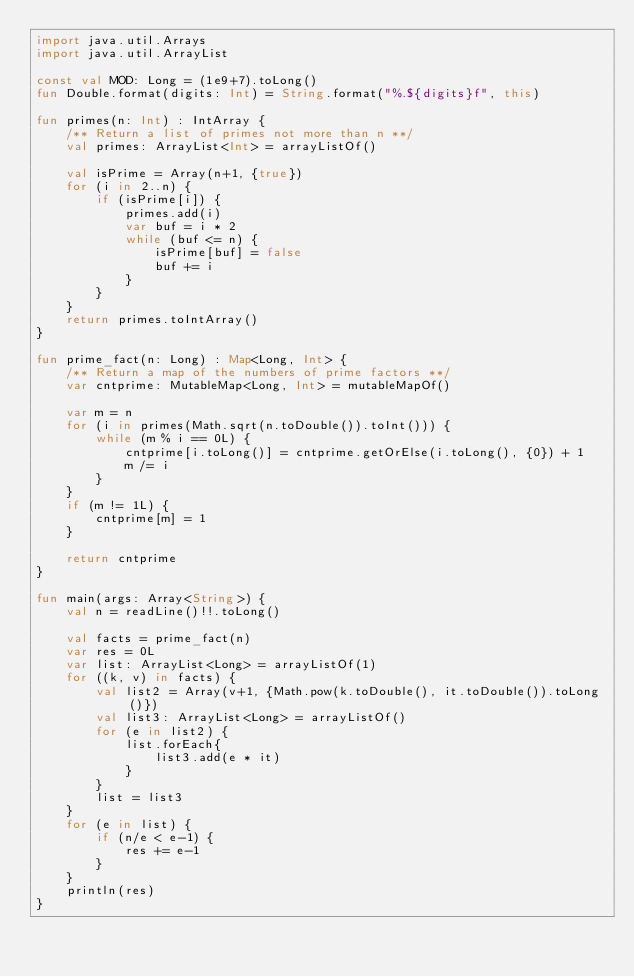<code> <loc_0><loc_0><loc_500><loc_500><_Kotlin_>import java.util.Arrays
import java.util.ArrayList

const val MOD: Long = (1e9+7).toLong()
fun Double.format(digits: Int) = String.format("%.${digits}f", this)

fun primes(n: Int) : IntArray {
    /** Return a list of primes not more than n **/
    val primes: ArrayList<Int> = arrayListOf()

    val isPrime = Array(n+1, {true})
    for (i in 2..n) {
        if (isPrime[i]) {
            primes.add(i)
            var buf = i * 2
            while (buf <= n) {
                isPrime[buf] = false
                buf += i
            }
        }
    }
    return primes.toIntArray()
}

fun prime_fact(n: Long) : Map<Long, Int> {
    /** Return a map of the numbers of prime factors **/
    var cntprime: MutableMap<Long, Int> = mutableMapOf()

    var m = n
    for (i in primes(Math.sqrt(n.toDouble()).toInt())) {
        while (m % i == 0L) {
            cntprime[i.toLong()] = cntprime.getOrElse(i.toLong(), {0}) + 1
            m /= i
        }
    }
    if (m != 1L) {
        cntprime[m] = 1
    }

    return cntprime
}

fun main(args: Array<String>) {
    val n = readLine()!!.toLong()

    val facts = prime_fact(n)
    var res = 0L
    var list: ArrayList<Long> = arrayListOf(1)
    for ((k, v) in facts) {
        val list2 = Array(v+1, {Math.pow(k.toDouble(), it.toDouble()).toLong()})
        val list3: ArrayList<Long> = arrayListOf()
        for (e in list2) {
            list.forEach{
                list3.add(e * it)
            }
        }
        list = list3
    }
    for (e in list) {
        if (n/e < e-1) {
            res += e-1
        }
    }
    println(res)
}
</code> 